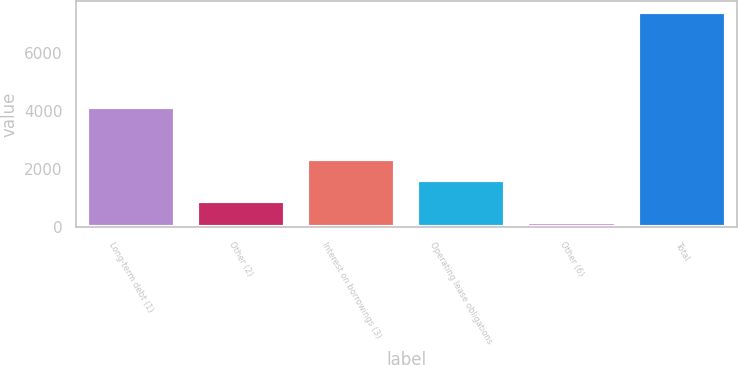Convert chart. <chart><loc_0><loc_0><loc_500><loc_500><bar_chart><fcel>Long-term debt (1)<fcel>Other (2)<fcel>Interest on borrowings (3)<fcel>Operating lease obligations<fcel>Other (6)<fcel>Total<nl><fcel>4132<fcel>912.1<fcel>2358.3<fcel>1635.2<fcel>189<fcel>7420<nl></chart> 